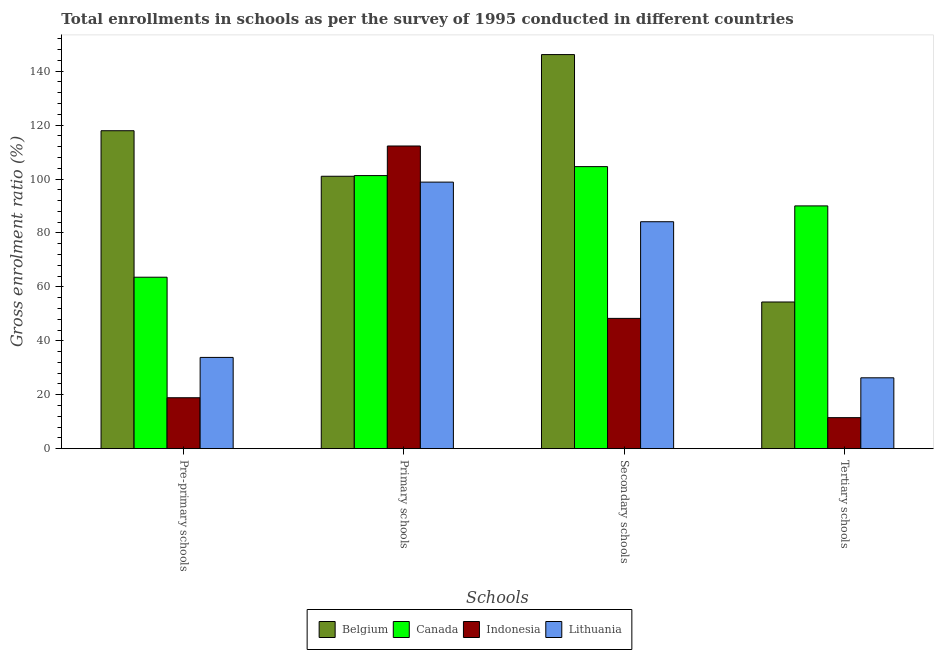How many different coloured bars are there?
Your answer should be compact. 4. How many groups of bars are there?
Your answer should be very brief. 4. Are the number of bars on each tick of the X-axis equal?
Your answer should be compact. Yes. How many bars are there on the 1st tick from the right?
Make the answer very short. 4. What is the label of the 1st group of bars from the left?
Offer a very short reply. Pre-primary schools. What is the gross enrolment ratio in primary schools in Lithuania?
Your answer should be very brief. 98.85. Across all countries, what is the maximum gross enrolment ratio in tertiary schools?
Make the answer very short. 90.04. Across all countries, what is the minimum gross enrolment ratio in tertiary schools?
Ensure brevity in your answer.  11.5. In which country was the gross enrolment ratio in pre-primary schools maximum?
Provide a short and direct response. Belgium. In which country was the gross enrolment ratio in primary schools minimum?
Provide a succinct answer. Lithuania. What is the total gross enrolment ratio in tertiary schools in the graph?
Your answer should be very brief. 182.22. What is the difference between the gross enrolment ratio in tertiary schools in Belgium and that in Canada?
Offer a terse response. -35.64. What is the difference between the gross enrolment ratio in primary schools in Belgium and the gross enrolment ratio in secondary schools in Lithuania?
Your answer should be compact. 16.86. What is the average gross enrolment ratio in secondary schools per country?
Your response must be concise. 95.81. What is the difference between the gross enrolment ratio in secondary schools and gross enrolment ratio in primary schools in Lithuania?
Your response must be concise. -14.68. In how many countries, is the gross enrolment ratio in tertiary schools greater than 56 %?
Offer a very short reply. 1. What is the ratio of the gross enrolment ratio in tertiary schools in Belgium to that in Indonesia?
Provide a short and direct response. 4.73. What is the difference between the highest and the second highest gross enrolment ratio in pre-primary schools?
Offer a very short reply. 54.32. What is the difference between the highest and the lowest gross enrolment ratio in tertiary schools?
Your answer should be very brief. 78.53. Is the sum of the gross enrolment ratio in tertiary schools in Lithuania and Belgium greater than the maximum gross enrolment ratio in pre-primary schools across all countries?
Provide a short and direct response. No. Is it the case that in every country, the sum of the gross enrolment ratio in secondary schools and gross enrolment ratio in pre-primary schools is greater than the sum of gross enrolment ratio in tertiary schools and gross enrolment ratio in primary schools?
Offer a terse response. No. What does the 1st bar from the right in Pre-primary schools represents?
Make the answer very short. Lithuania. Is it the case that in every country, the sum of the gross enrolment ratio in pre-primary schools and gross enrolment ratio in primary schools is greater than the gross enrolment ratio in secondary schools?
Your answer should be very brief. Yes. How many bars are there?
Provide a succinct answer. 16. Are all the bars in the graph horizontal?
Ensure brevity in your answer.  No. Are the values on the major ticks of Y-axis written in scientific E-notation?
Offer a terse response. No. Where does the legend appear in the graph?
Your response must be concise. Bottom center. How are the legend labels stacked?
Your response must be concise. Horizontal. What is the title of the graph?
Ensure brevity in your answer.  Total enrollments in schools as per the survey of 1995 conducted in different countries. What is the label or title of the X-axis?
Your answer should be very brief. Schools. What is the Gross enrolment ratio (%) of Belgium in Pre-primary schools?
Ensure brevity in your answer.  117.91. What is the Gross enrolment ratio (%) in Canada in Pre-primary schools?
Give a very brief answer. 63.59. What is the Gross enrolment ratio (%) in Indonesia in Pre-primary schools?
Offer a very short reply. 18.89. What is the Gross enrolment ratio (%) in Lithuania in Pre-primary schools?
Make the answer very short. 33.84. What is the Gross enrolment ratio (%) in Belgium in Primary schools?
Your answer should be very brief. 101.02. What is the Gross enrolment ratio (%) of Canada in Primary schools?
Keep it short and to the point. 101.27. What is the Gross enrolment ratio (%) in Indonesia in Primary schools?
Offer a very short reply. 112.25. What is the Gross enrolment ratio (%) of Lithuania in Primary schools?
Offer a terse response. 98.85. What is the Gross enrolment ratio (%) of Belgium in Secondary schools?
Provide a short and direct response. 146.15. What is the Gross enrolment ratio (%) of Canada in Secondary schools?
Provide a short and direct response. 104.6. What is the Gross enrolment ratio (%) in Indonesia in Secondary schools?
Make the answer very short. 48.32. What is the Gross enrolment ratio (%) in Lithuania in Secondary schools?
Your answer should be compact. 84.17. What is the Gross enrolment ratio (%) in Belgium in Tertiary schools?
Your answer should be very brief. 54.4. What is the Gross enrolment ratio (%) of Canada in Tertiary schools?
Keep it short and to the point. 90.04. What is the Gross enrolment ratio (%) in Indonesia in Tertiary schools?
Your response must be concise. 11.5. What is the Gross enrolment ratio (%) of Lithuania in Tertiary schools?
Ensure brevity in your answer.  26.28. Across all Schools, what is the maximum Gross enrolment ratio (%) in Belgium?
Ensure brevity in your answer.  146.15. Across all Schools, what is the maximum Gross enrolment ratio (%) of Canada?
Offer a terse response. 104.6. Across all Schools, what is the maximum Gross enrolment ratio (%) of Indonesia?
Provide a short and direct response. 112.25. Across all Schools, what is the maximum Gross enrolment ratio (%) in Lithuania?
Offer a terse response. 98.85. Across all Schools, what is the minimum Gross enrolment ratio (%) in Belgium?
Offer a very short reply. 54.4. Across all Schools, what is the minimum Gross enrolment ratio (%) in Canada?
Make the answer very short. 63.59. Across all Schools, what is the minimum Gross enrolment ratio (%) of Indonesia?
Offer a terse response. 11.5. Across all Schools, what is the minimum Gross enrolment ratio (%) of Lithuania?
Provide a short and direct response. 26.28. What is the total Gross enrolment ratio (%) in Belgium in the graph?
Provide a short and direct response. 419.48. What is the total Gross enrolment ratio (%) in Canada in the graph?
Keep it short and to the point. 359.5. What is the total Gross enrolment ratio (%) of Indonesia in the graph?
Offer a very short reply. 190.96. What is the total Gross enrolment ratio (%) in Lithuania in the graph?
Your response must be concise. 243.14. What is the difference between the Gross enrolment ratio (%) of Belgium in Pre-primary schools and that in Primary schools?
Provide a succinct answer. 16.89. What is the difference between the Gross enrolment ratio (%) of Canada in Pre-primary schools and that in Primary schools?
Your answer should be compact. -37.69. What is the difference between the Gross enrolment ratio (%) of Indonesia in Pre-primary schools and that in Primary schools?
Give a very brief answer. -93.36. What is the difference between the Gross enrolment ratio (%) of Lithuania in Pre-primary schools and that in Primary schools?
Your answer should be very brief. -65.01. What is the difference between the Gross enrolment ratio (%) of Belgium in Pre-primary schools and that in Secondary schools?
Your response must be concise. -28.24. What is the difference between the Gross enrolment ratio (%) of Canada in Pre-primary schools and that in Secondary schools?
Your response must be concise. -41.01. What is the difference between the Gross enrolment ratio (%) in Indonesia in Pre-primary schools and that in Secondary schools?
Make the answer very short. -29.43. What is the difference between the Gross enrolment ratio (%) in Lithuania in Pre-primary schools and that in Secondary schools?
Give a very brief answer. -50.32. What is the difference between the Gross enrolment ratio (%) in Belgium in Pre-primary schools and that in Tertiary schools?
Provide a succinct answer. 63.51. What is the difference between the Gross enrolment ratio (%) of Canada in Pre-primary schools and that in Tertiary schools?
Give a very brief answer. -26.45. What is the difference between the Gross enrolment ratio (%) of Indonesia in Pre-primary schools and that in Tertiary schools?
Make the answer very short. 7.38. What is the difference between the Gross enrolment ratio (%) in Lithuania in Pre-primary schools and that in Tertiary schools?
Your response must be concise. 7.56. What is the difference between the Gross enrolment ratio (%) of Belgium in Primary schools and that in Secondary schools?
Offer a very short reply. -45.13. What is the difference between the Gross enrolment ratio (%) in Canada in Primary schools and that in Secondary schools?
Your response must be concise. -3.33. What is the difference between the Gross enrolment ratio (%) of Indonesia in Primary schools and that in Secondary schools?
Your answer should be very brief. 63.93. What is the difference between the Gross enrolment ratio (%) in Lithuania in Primary schools and that in Secondary schools?
Your answer should be compact. 14.68. What is the difference between the Gross enrolment ratio (%) in Belgium in Primary schools and that in Tertiary schools?
Ensure brevity in your answer.  46.62. What is the difference between the Gross enrolment ratio (%) of Canada in Primary schools and that in Tertiary schools?
Offer a terse response. 11.24. What is the difference between the Gross enrolment ratio (%) in Indonesia in Primary schools and that in Tertiary schools?
Your response must be concise. 100.74. What is the difference between the Gross enrolment ratio (%) in Lithuania in Primary schools and that in Tertiary schools?
Provide a short and direct response. 72.57. What is the difference between the Gross enrolment ratio (%) of Belgium in Secondary schools and that in Tertiary schools?
Give a very brief answer. 91.75. What is the difference between the Gross enrolment ratio (%) in Canada in Secondary schools and that in Tertiary schools?
Offer a very short reply. 14.57. What is the difference between the Gross enrolment ratio (%) in Indonesia in Secondary schools and that in Tertiary schools?
Your response must be concise. 36.82. What is the difference between the Gross enrolment ratio (%) of Lithuania in Secondary schools and that in Tertiary schools?
Offer a terse response. 57.88. What is the difference between the Gross enrolment ratio (%) in Belgium in Pre-primary schools and the Gross enrolment ratio (%) in Canada in Primary schools?
Provide a succinct answer. 16.64. What is the difference between the Gross enrolment ratio (%) of Belgium in Pre-primary schools and the Gross enrolment ratio (%) of Indonesia in Primary schools?
Provide a succinct answer. 5.66. What is the difference between the Gross enrolment ratio (%) in Belgium in Pre-primary schools and the Gross enrolment ratio (%) in Lithuania in Primary schools?
Offer a very short reply. 19.06. What is the difference between the Gross enrolment ratio (%) in Canada in Pre-primary schools and the Gross enrolment ratio (%) in Indonesia in Primary schools?
Give a very brief answer. -48.66. What is the difference between the Gross enrolment ratio (%) of Canada in Pre-primary schools and the Gross enrolment ratio (%) of Lithuania in Primary schools?
Make the answer very short. -35.26. What is the difference between the Gross enrolment ratio (%) in Indonesia in Pre-primary schools and the Gross enrolment ratio (%) in Lithuania in Primary schools?
Provide a short and direct response. -79.96. What is the difference between the Gross enrolment ratio (%) of Belgium in Pre-primary schools and the Gross enrolment ratio (%) of Canada in Secondary schools?
Ensure brevity in your answer.  13.31. What is the difference between the Gross enrolment ratio (%) in Belgium in Pre-primary schools and the Gross enrolment ratio (%) in Indonesia in Secondary schools?
Keep it short and to the point. 69.59. What is the difference between the Gross enrolment ratio (%) of Belgium in Pre-primary schools and the Gross enrolment ratio (%) of Lithuania in Secondary schools?
Your answer should be compact. 33.75. What is the difference between the Gross enrolment ratio (%) in Canada in Pre-primary schools and the Gross enrolment ratio (%) in Indonesia in Secondary schools?
Ensure brevity in your answer.  15.27. What is the difference between the Gross enrolment ratio (%) of Canada in Pre-primary schools and the Gross enrolment ratio (%) of Lithuania in Secondary schools?
Give a very brief answer. -20.58. What is the difference between the Gross enrolment ratio (%) in Indonesia in Pre-primary schools and the Gross enrolment ratio (%) in Lithuania in Secondary schools?
Keep it short and to the point. -65.28. What is the difference between the Gross enrolment ratio (%) of Belgium in Pre-primary schools and the Gross enrolment ratio (%) of Canada in Tertiary schools?
Your response must be concise. 27.88. What is the difference between the Gross enrolment ratio (%) of Belgium in Pre-primary schools and the Gross enrolment ratio (%) of Indonesia in Tertiary schools?
Ensure brevity in your answer.  106.41. What is the difference between the Gross enrolment ratio (%) of Belgium in Pre-primary schools and the Gross enrolment ratio (%) of Lithuania in Tertiary schools?
Provide a succinct answer. 91.63. What is the difference between the Gross enrolment ratio (%) of Canada in Pre-primary schools and the Gross enrolment ratio (%) of Indonesia in Tertiary schools?
Provide a short and direct response. 52.09. What is the difference between the Gross enrolment ratio (%) of Canada in Pre-primary schools and the Gross enrolment ratio (%) of Lithuania in Tertiary schools?
Your answer should be compact. 37.31. What is the difference between the Gross enrolment ratio (%) in Indonesia in Pre-primary schools and the Gross enrolment ratio (%) in Lithuania in Tertiary schools?
Your answer should be compact. -7.39. What is the difference between the Gross enrolment ratio (%) in Belgium in Primary schools and the Gross enrolment ratio (%) in Canada in Secondary schools?
Keep it short and to the point. -3.58. What is the difference between the Gross enrolment ratio (%) of Belgium in Primary schools and the Gross enrolment ratio (%) of Indonesia in Secondary schools?
Your answer should be compact. 52.7. What is the difference between the Gross enrolment ratio (%) in Belgium in Primary schools and the Gross enrolment ratio (%) in Lithuania in Secondary schools?
Offer a terse response. 16.86. What is the difference between the Gross enrolment ratio (%) of Canada in Primary schools and the Gross enrolment ratio (%) of Indonesia in Secondary schools?
Your answer should be compact. 52.96. What is the difference between the Gross enrolment ratio (%) of Canada in Primary schools and the Gross enrolment ratio (%) of Lithuania in Secondary schools?
Ensure brevity in your answer.  17.11. What is the difference between the Gross enrolment ratio (%) in Indonesia in Primary schools and the Gross enrolment ratio (%) in Lithuania in Secondary schools?
Offer a very short reply. 28.08. What is the difference between the Gross enrolment ratio (%) of Belgium in Primary schools and the Gross enrolment ratio (%) of Canada in Tertiary schools?
Provide a short and direct response. 10.99. What is the difference between the Gross enrolment ratio (%) in Belgium in Primary schools and the Gross enrolment ratio (%) in Indonesia in Tertiary schools?
Provide a succinct answer. 89.52. What is the difference between the Gross enrolment ratio (%) of Belgium in Primary schools and the Gross enrolment ratio (%) of Lithuania in Tertiary schools?
Make the answer very short. 74.74. What is the difference between the Gross enrolment ratio (%) in Canada in Primary schools and the Gross enrolment ratio (%) in Indonesia in Tertiary schools?
Your response must be concise. 89.77. What is the difference between the Gross enrolment ratio (%) in Canada in Primary schools and the Gross enrolment ratio (%) in Lithuania in Tertiary schools?
Offer a terse response. 74.99. What is the difference between the Gross enrolment ratio (%) of Indonesia in Primary schools and the Gross enrolment ratio (%) of Lithuania in Tertiary schools?
Give a very brief answer. 85.97. What is the difference between the Gross enrolment ratio (%) in Belgium in Secondary schools and the Gross enrolment ratio (%) in Canada in Tertiary schools?
Your answer should be very brief. 56.11. What is the difference between the Gross enrolment ratio (%) of Belgium in Secondary schools and the Gross enrolment ratio (%) of Indonesia in Tertiary schools?
Offer a terse response. 134.65. What is the difference between the Gross enrolment ratio (%) of Belgium in Secondary schools and the Gross enrolment ratio (%) of Lithuania in Tertiary schools?
Keep it short and to the point. 119.87. What is the difference between the Gross enrolment ratio (%) in Canada in Secondary schools and the Gross enrolment ratio (%) in Indonesia in Tertiary schools?
Keep it short and to the point. 93.1. What is the difference between the Gross enrolment ratio (%) of Canada in Secondary schools and the Gross enrolment ratio (%) of Lithuania in Tertiary schools?
Ensure brevity in your answer.  78.32. What is the difference between the Gross enrolment ratio (%) in Indonesia in Secondary schools and the Gross enrolment ratio (%) in Lithuania in Tertiary schools?
Give a very brief answer. 22.04. What is the average Gross enrolment ratio (%) in Belgium per Schools?
Provide a short and direct response. 104.87. What is the average Gross enrolment ratio (%) in Canada per Schools?
Ensure brevity in your answer.  89.87. What is the average Gross enrolment ratio (%) in Indonesia per Schools?
Offer a very short reply. 47.74. What is the average Gross enrolment ratio (%) of Lithuania per Schools?
Offer a terse response. 60.78. What is the difference between the Gross enrolment ratio (%) in Belgium and Gross enrolment ratio (%) in Canada in Pre-primary schools?
Offer a terse response. 54.32. What is the difference between the Gross enrolment ratio (%) in Belgium and Gross enrolment ratio (%) in Indonesia in Pre-primary schools?
Your response must be concise. 99.02. What is the difference between the Gross enrolment ratio (%) of Belgium and Gross enrolment ratio (%) of Lithuania in Pre-primary schools?
Make the answer very short. 84.07. What is the difference between the Gross enrolment ratio (%) in Canada and Gross enrolment ratio (%) in Indonesia in Pre-primary schools?
Your answer should be compact. 44.7. What is the difference between the Gross enrolment ratio (%) of Canada and Gross enrolment ratio (%) of Lithuania in Pre-primary schools?
Give a very brief answer. 29.75. What is the difference between the Gross enrolment ratio (%) of Indonesia and Gross enrolment ratio (%) of Lithuania in Pre-primary schools?
Make the answer very short. -14.95. What is the difference between the Gross enrolment ratio (%) of Belgium and Gross enrolment ratio (%) of Canada in Primary schools?
Keep it short and to the point. -0.25. What is the difference between the Gross enrolment ratio (%) in Belgium and Gross enrolment ratio (%) in Indonesia in Primary schools?
Your answer should be compact. -11.22. What is the difference between the Gross enrolment ratio (%) in Belgium and Gross enrolment ratio (%) in Lithuania in Primary schools?
Make the answer very short. 2.17. What is the difference between the Gross enrolment ratio (%) in Canada and Gross enrolment ratio (%) in Indonesia in Primary schools?
Offer a terse response. -10.97. What is the difference between the Gross enrolment ratio (%) of Canada and Gross enrolment ratio (%) of Lithuania in Primary schools?
Your answer should be very brief. 2.42. What is the difference between the Gross enrolment ratio (%) in Indonesia and Gross enrolment ratio (%) in Lithuania in Primary schools?
Keep it short and to the point. 13.4. What is the difference between the Gross enrolment ratio (%) of Belgium and Gross enrolment ratio (%) of Canada in Secondary schools?
Offer a very short reply. 41.55. What is the difference between the Gross enrolment ratio (%) of Belgium and Gross enrolment ratio (%) of Indonesia in Secondary schools?
Make the answer very short. 97.83. What is the difference between the Gross enrolment ratio (%) of Belgium and Gross enrolment ratio (%) of Lithuania in Secondary schools?
Keep it short and to the point. 61.98. What is the difference between the Gross enrolment ratio (%) in Canada and Gross enrolment ratio (%) in Indonesia in Secondary schools?
Provide a short and direct response. 56.28. What is the difference between the Gross enrolment ratio (%) of Canada and Gross enrolment ratio (%) of Lithuania in Secondary schools?
Provide a short and direct response. 20.43. What is the difference between the Gross enrolment ratio (%) of Indonesia and Gross enrolment ratio (%) of Lithuania in Secondary schools?
Your response must be concise. -35.85. What is the difference between the Gross enrolment ratio (%) in Belgium and Gross enrolment ratio (%) in Canada in Tertiary schools?
Keep it short and to the point. -35.64. What is the difference between the Gross enrolment ratio (%) in Belgium and Gross enrolment ratio (%) in Indonesia in Tertiary schools?
Make the answer very short. 42.9. What is the difference between the Gross enrolment ratio (%) in Belgium and Gross enrolment ratio (%) in Lithuania in Tertiary schools?
Give a very brief answer. 28.12. What is the difference between the Gross enrolment ratio (%) in Canada and Gross enrolment ratio (%) in Indonesia in Tertiary schools?
Make the answer very short. 78.53. What is the difference between the Gross enrolment ratio (%) of Canada and Gross enrolment ratio (%) of Lithuania in Tertiary schools?
Give a very brief answer. 63.75. What is the difference between the Gross enrolment ratio (%) of Indonesia and Gross enrolment ratio (%) of Lithuania in Tertiary schools?
Offer a very short reply. -14.78. What is the ratio of the Gross enrolment ratio (%) in Belgium in Pre-primary schools to that in Primary schools?
Make the answer very short. 1.17. What is the ratio of the Gross enrolment ratio (%) of Canada in Pre-primary schools to that in Primary schools?
Offer a very short reply. 0.63. What is the ratio of the Gross enrolment ratio (%) in Indonesia in Pre-primary schools to that in Primary schools?
Make the answer very short. 0.17. What is the ratio of the Gross enrolment ratio (%) of Lithuania in Pre-primary schools to that in Primary schools?
Ensure brevity in your answer.  0.34. What is the ratio of the Gross enrolment ratio (%) of Belgium in Pre-primary schools to that in Secondary schools?
Offer a terse response. 0.81. What is the ratio of the Gross enrolment ratio (%) in Canada in Pre-primary schools to that in Secondary schools?
Offer a very short reply. 0.61. What is the ratio of the Gross enrolment ratio (%) of Indonesia in Pre-primary schools to that in Secondary schools?
Give a very brief answer. 0.39. What is the ratio of the Gross enrolment ratio (%) of Lithuania in Pre-primary schools to that in Secondary schools?
Make the answer very short. 0.4. What is the ratio of the Gross enrolment ratio (%) of Belgium in Pre-primary schools to that in Tertiary schools?
Provide a succinct answer. 2.17. What is the ratio of the Gross enrolment ratio (%) of Canada in Pre-primary schools to that in Tertiary schools?
Your response must be concise. 0.71. What is the ratio of the Gross enrolment ratio (%) in Indonesia in Pre-primary schools to that in Tertiary schools?
Your answer should be very brief. 1.64. What is the ratio of the Gross enrolment ratio (%) in Lithuania in Pre-primary schools to that in Tertiary schools?
Ensure brevity in your answer.  1.29. What is the ratio of the Gross enrolment ratio (%) in Belgium in Primary schools to that in Secondary schools?
Provide a succinct answer. 0.69. What is the ratio of the Gross enrolment ratio (%) of Canada in Primary schools to that in Secondary schools?
Provide a short and direct response. 0.97. What is the ratio of the Gross enrolment ratio (%) in Indonesia in Primary schools to that in Secondary schools?
Make the answer very short. 2.32. What is the ratio of the Gross enrolment ratio (%) of Lithuania in Primary schools to that in Secondary schools?
Provide a short and direct response. 1.17. What is the ratio of the Gross enrolment ratio (%) of Belgium in Primary schools to that in Tertiary schools?
Offer a terse response. 1.86. What is the ratio of the Gross enrolment ratio (%) of Canada in Primary schools to that in Tertiary schools?
Offer a terse response. 1.12. What is the ratio of the Gross enrolment ratio (%) in Indonesia in Primary schools to that in Tertiary schools?
Provide a short and direct response. 9.76. What is the ratio of the Gross enrolment ratio (%) in Lithuania in Primary schools to that in Tertiary schools?
Offer a very short reply. 3.76. What is the ratio of the Gross enrolment ratio (%) in Belgium in Secondary schools to that in Tertiary schools?
Provide a short and direct response. 2.69. What is the ratio of the Gross enrolment ratio (%) of Canada in Secondary schools to that in Tertiary schools?
Offer a very short reply. 1.16. What is the ratio of the Gross enrolment ratio (%) in Indonesia in Secondary schools to that in Tertiary schools?
Provide a short and direct response. 4.2. What is the ratio of the Gross enrolment ratio (%) in Lithuania in Secondary schools to that in Tertiary schools?
Offer a very short reply. 3.2. What is the difference between the highest and the second highest Gross enrolment ratio (%) in Belgium?
Give a very brief answer. 28.24. What is the difference between the highest and the second highest Gross enrolment ratio (%) of Canada?
Your answer should be compact. 3.33. What is the difference between the highest and the second highest Gross enrolment ratio (%) in Indonesia?
Give a very brief answer. 63.93. What is the difference between the highest and the second highest Gross enrolment ratio (%) in Lithuania?
Make the answer very short. 14.68. What is the difference between the highest and the lowest Gross enrolment ratio (%) of Belgium?
Ensure brevity in your answer.  91.75. What is the difference between the highest and the lowest Gross enrolment ratio (%) of Canada?
Make the answer very short. 41.01. What is the difference between the highest and the lowest Gross enrolment ratio (%) in Indonesia?
Make the answer very short. 100.74. What is the difference between the highest and the lowest Gross enrolment ratio (%) in Lithuania?
Ensure brevity in your answer.  72.57. 